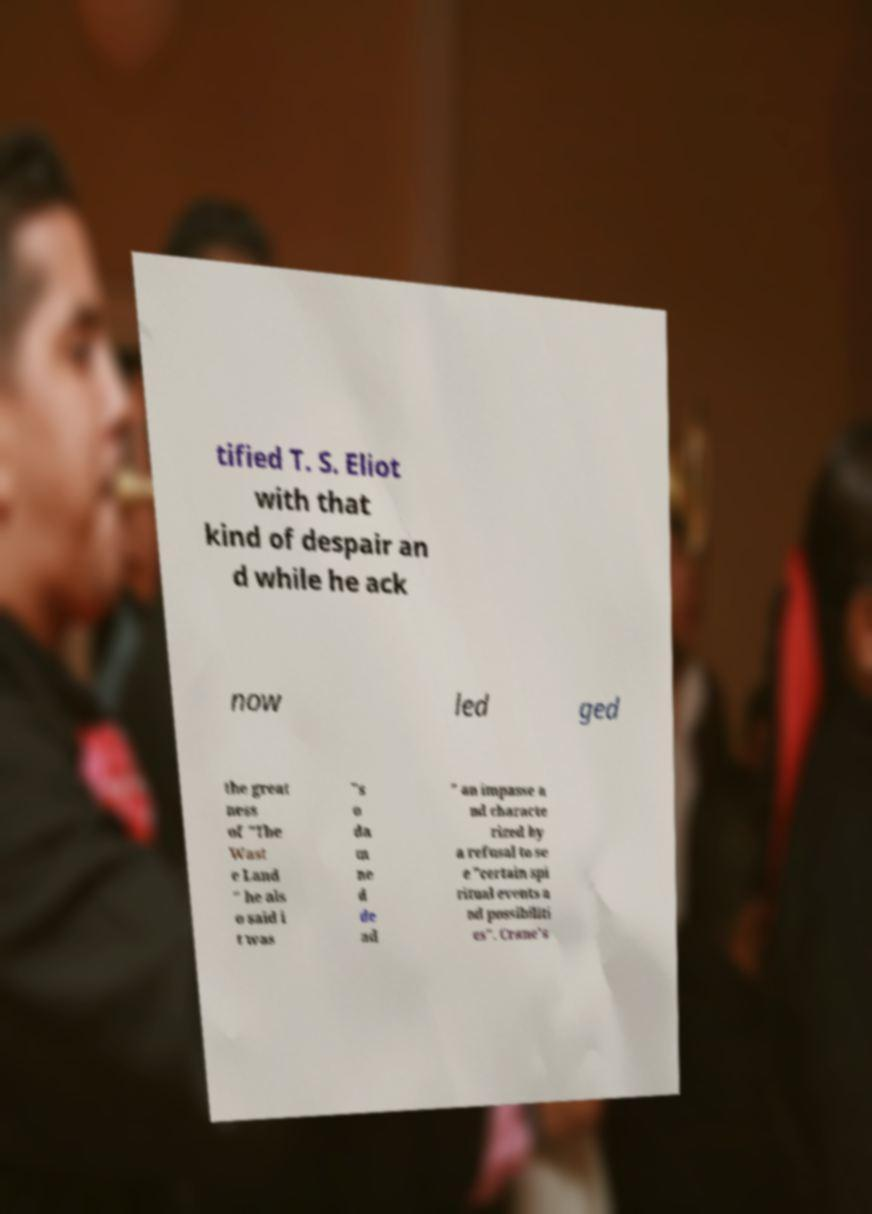What messages or text are displayed in this image? I need them in a readable, typed format. tified T. S. Eliot with that kind of despair an d while he ack now led ged the great ness of "The Wast e Land " he als o said i t was "s o da m ne d de ad " an impasse a nd characte rized by a refusal to se e "certain spi ritual events a nd possibiliti es". Crane's 